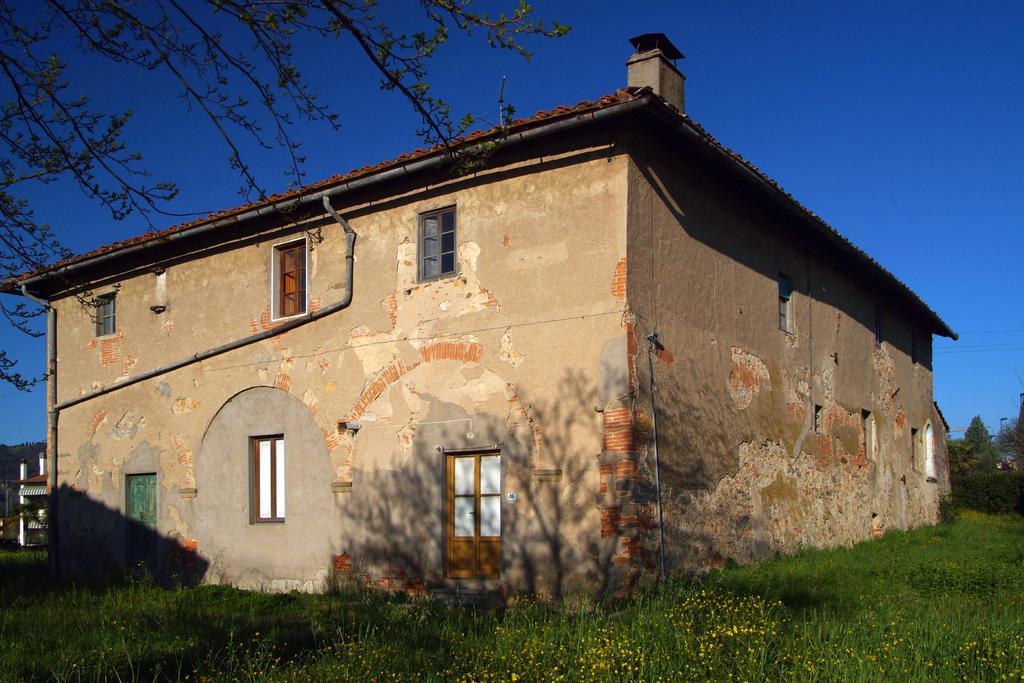How would you summarize this image in a sentence or two? In this image we can see grass, building with windows and doors, on the right side we can see some trees. 